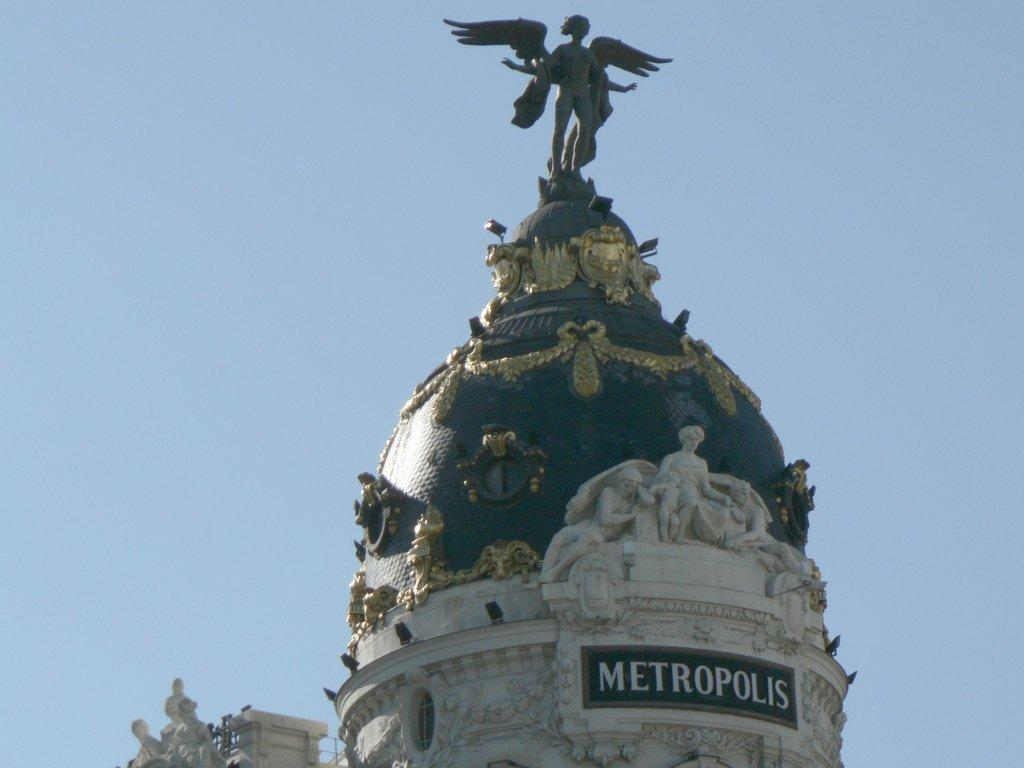What is the main subject of the image? There is a monument in the image. What features can be seen on the monument? The monument has sculpture and statues. What can be seen in the background of the image? The sky is visible in the background of the image. What is the color of the sky in the image? The sky is blue in color. What type of sound can be heard coming from the quarter in the image? There is no quarter present in the image, so it is not possible to determine what sound might be heard. 